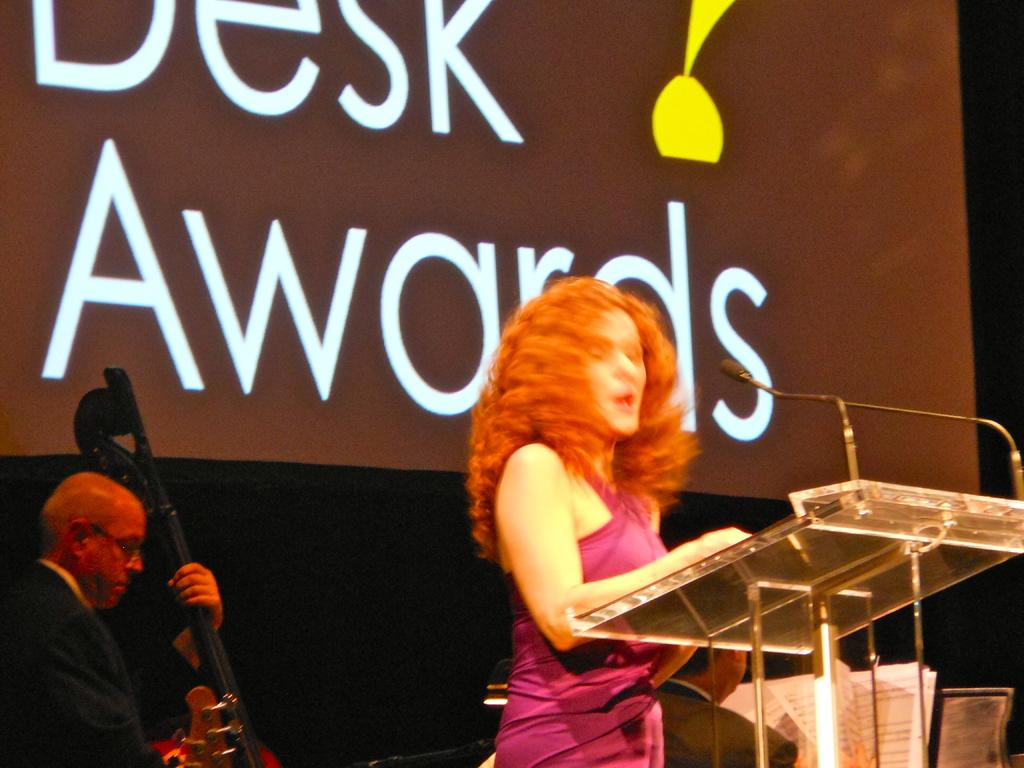What is the woman in the image doing? The woman is standing in the image. What object is present in the image that is typically used for amplifying sound? There is a microphone in the image. What piece of furniture is present in the image that is often used for speeches or presentations? There is a podium in the image. What is the man in the image doing? The man is playing a musical instrument in the image. What can be seen in the background of the image? There is a poster visible in the background of the image. Where is the oven located in the image? There is no oven present in the image. What type of carriage can be seen in the image? There is no carriage present in the image. 